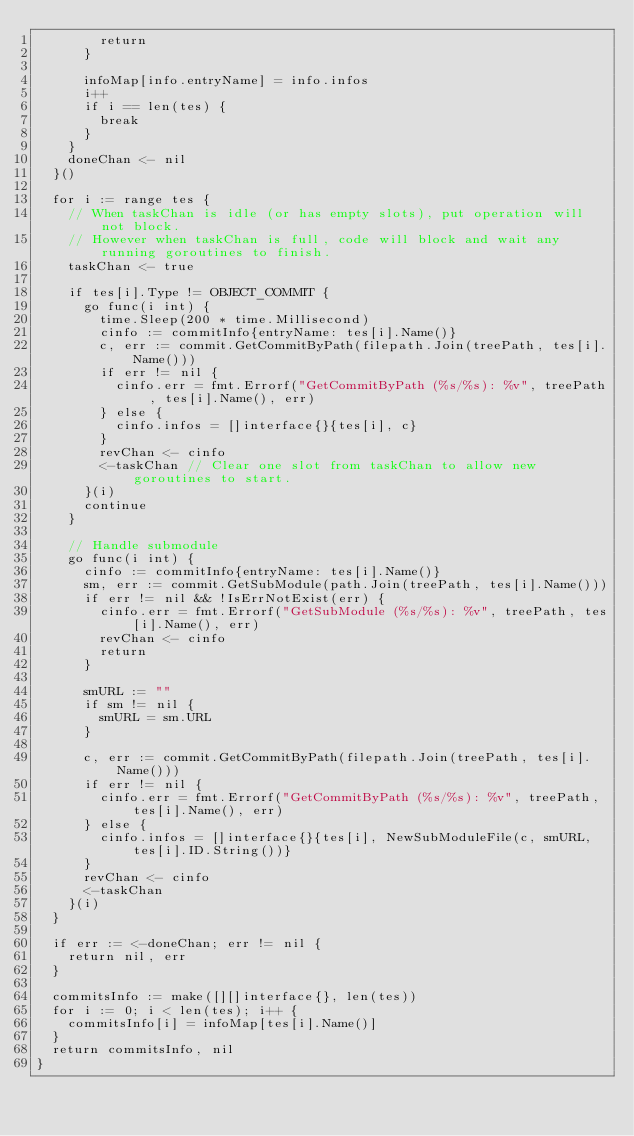<code> <loc_0><loc_0><loc_500><loc_500><_Go_>				return
			}

			infoMap[info.entryName] = info.infos
			i++
			if i == len(tes) {
				break
			}
		}
		doneChan <- nil
	}()

	for i := range tes {
		// When taskChan is idle (or has empty slots), put operation will not block.
		// However when taskChan is full, code will block and wait any running goroutines to finish.
		taskChan <- true

		if tes[i].Type != OBJECT_COMMIT {
			go func(i int) {
				time.Sleep(200 * time.Millisecond)
				cinfo := commitInfo{entryName: tes[i].Name()}
				c, err := commit.GetCommitByPath(filepath.Join(treePath, tes[i].Name()))
				if err != nil {
					cinfo.err = fmt.Errorf("GetCommitByPath (%s/%s): %v", treePath, tes[i].Name(), err)
				} else {
					cinfo.infos = []interface{}{tes[i], c}
				}
				revChan <- cinfo
				<-taskChan // Clear one slot from taskChan to allow new goroutines to start.
			}(i)
			continue
		}

		// Handle submodule
		go func(i int) {
			cinfo := commitInfo{entryName: tes[i].Name()}
			sm, err := commit.GetSubModule(path.Join(treePath, tes[i].Name()))
			if err != nil && !IsErrNotExist(err) {
				cinfo.err = fmt.Errorf("GetSubModule (%s/%s): %v", treePath, tes[i].Name(), err)
				revChan <- cinfo
				return
			}

			smURL := ""
			if sm != nil {
				smURL = sm.URL
			}

			c, err := commit.GetCommitByPath(filepath.Join(treePath, tes[i].Name()))
			if err != nil {
				cinfo.err = fmt.Errorf("GetCommitByPath (%s/%s): %v", treePath, tes[i].Name(), err)
			} else {
				cinfo.infos = []interface{}{tes[i], NewSubModuleFile(c, smURL, tes[i].ID.String())}
			}
			revChan <- cinfo
			<-taskChan
		}(i)
	}

	if err := <-doneChan; err != nil {
		return nil, err
	}

	commitsInfo := make([][]interface{}, len(tes))
	for i := 0; i < len(tes); i++ {
		commitsInfo[i] = infoMap[tes[i].Name()]
	}
	return commitsInfo, nil
}
</code> 